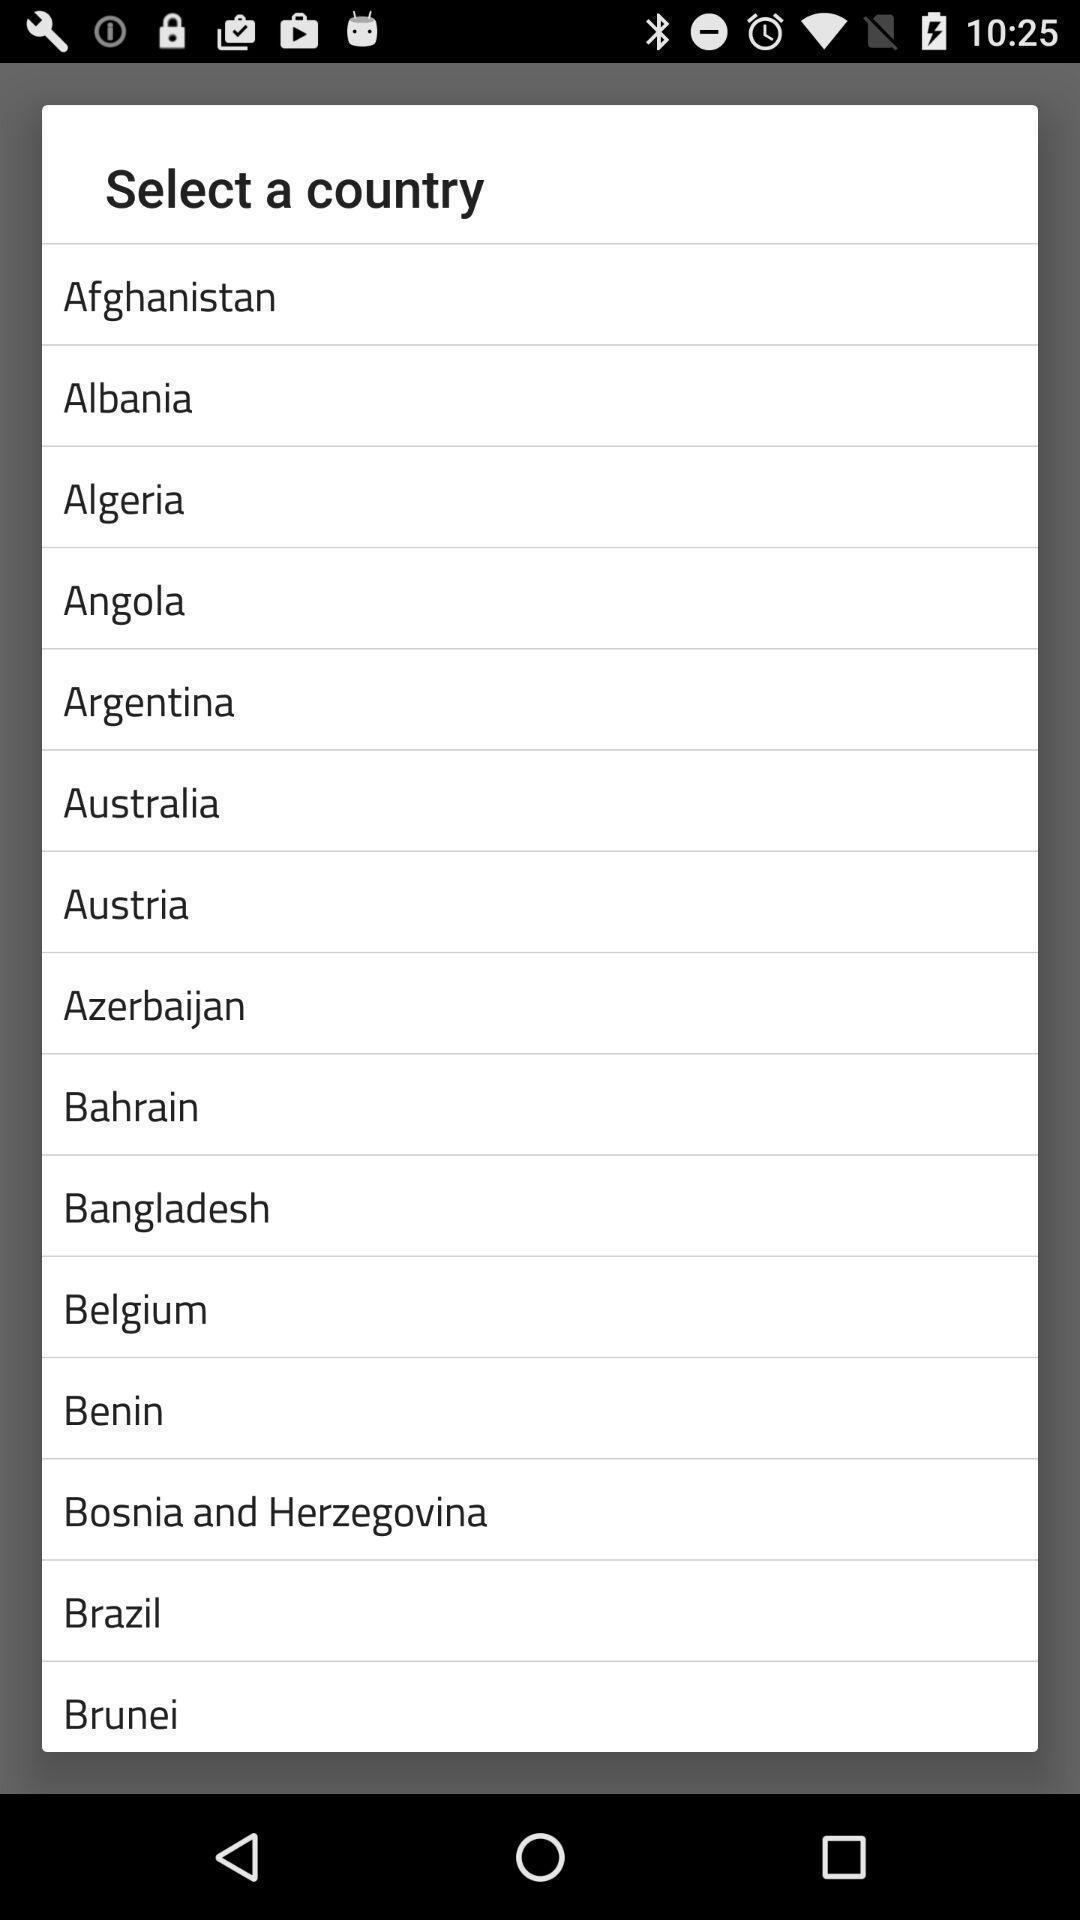Explain what's happening in this screen capture. Pop-up asking to select a country. 